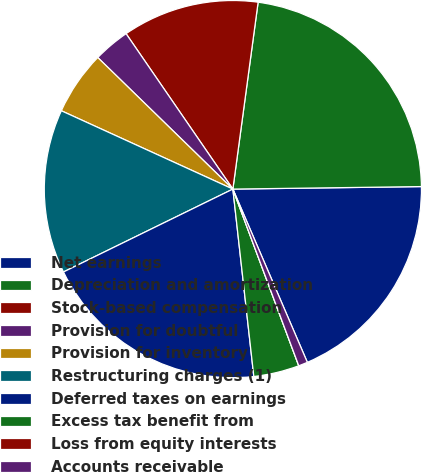<chart> <loc_0><loc_0><loc_500><loc_500><pie_chart><fcel>Net earnings<fcel>Depreciation and amortization<fcel>Stock-based compensation<fcel>Provision for doubtful<fcel>Provision for inventory<fcel>Restructuring charges (1)<fcel>Deferred taxes on earnings<fcel>Excess tax benefit from<fcel>Loss from equity interests<fcel>Accounts receivable<nl><fcel>18.75%<fcel>22.65%<fcel>11.72%<fcel>3.13%<fcel>5.47%<fcel>14.06%<fcel>19.53%<fcel>3.91%<fcel>0.0%<fcel>0.78%<nl></chart> 